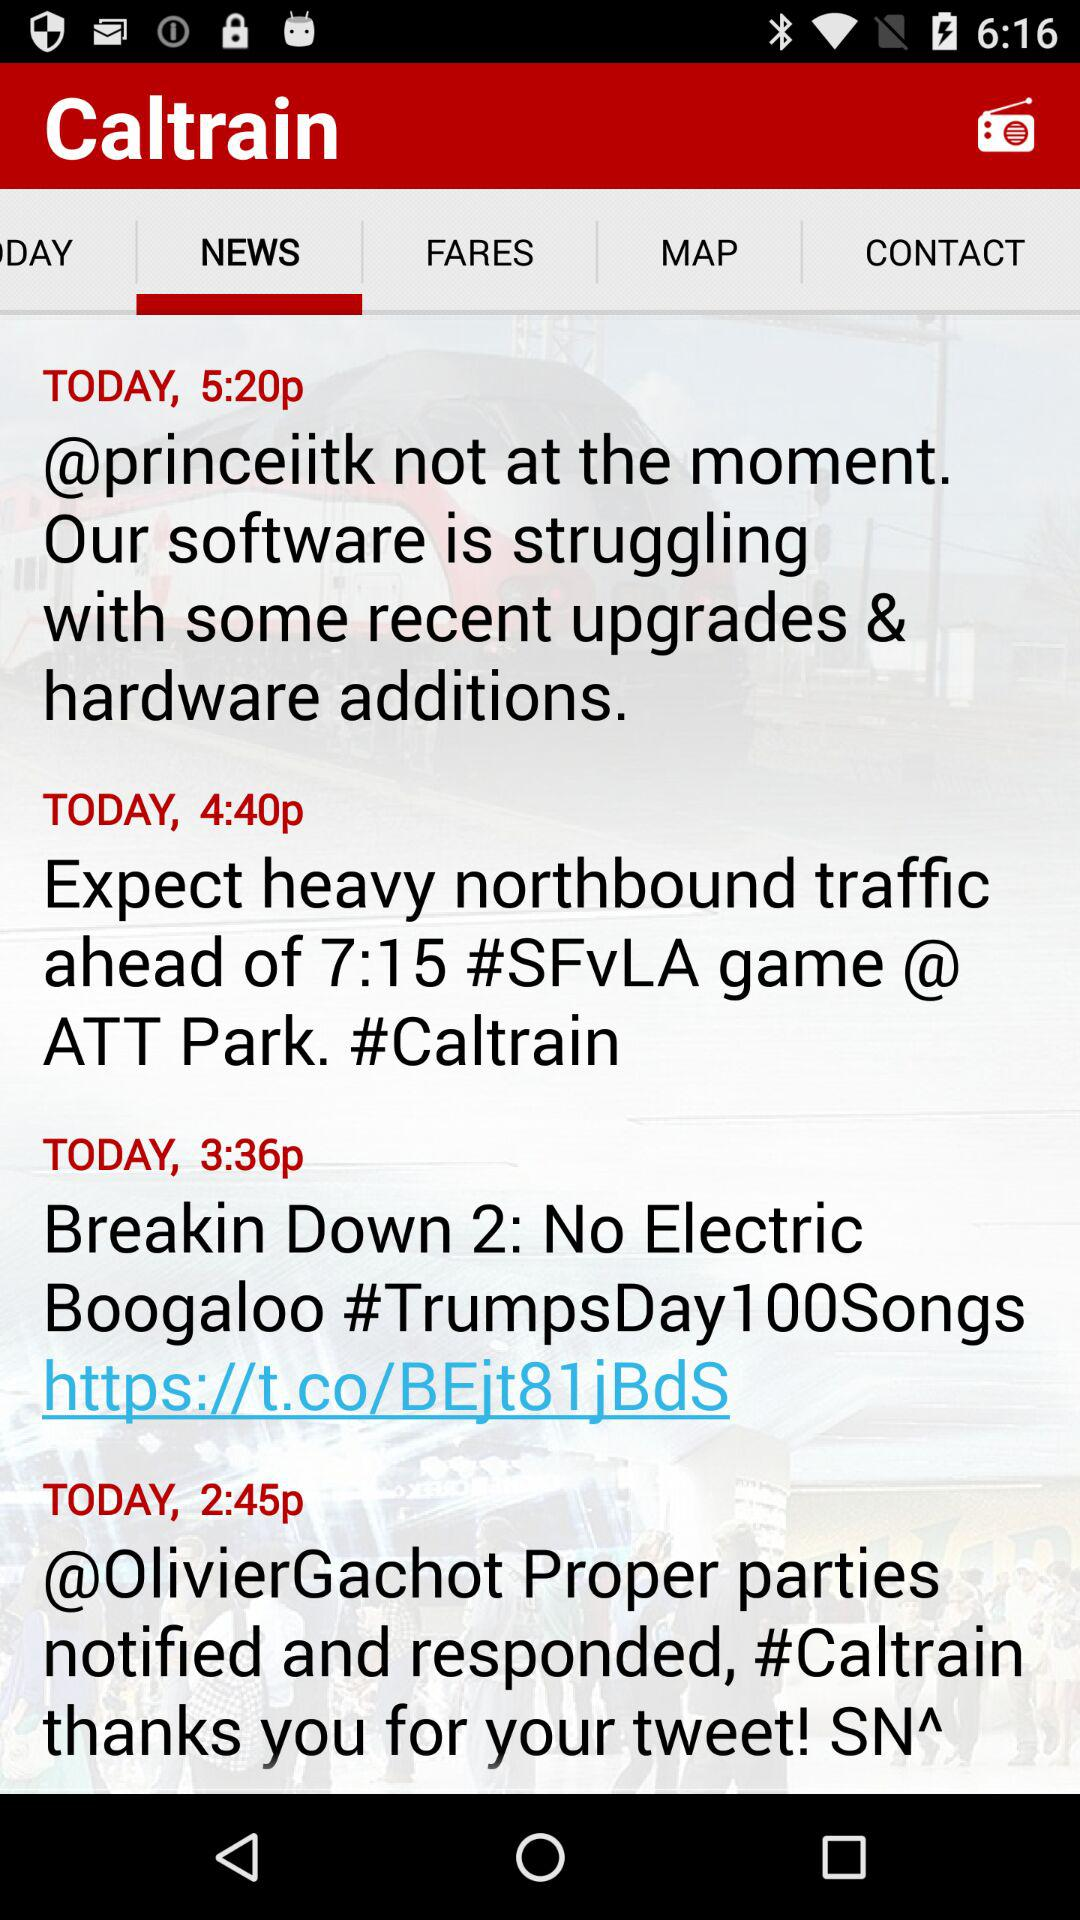Which tab is selected? The selected tab is "NEWS". 